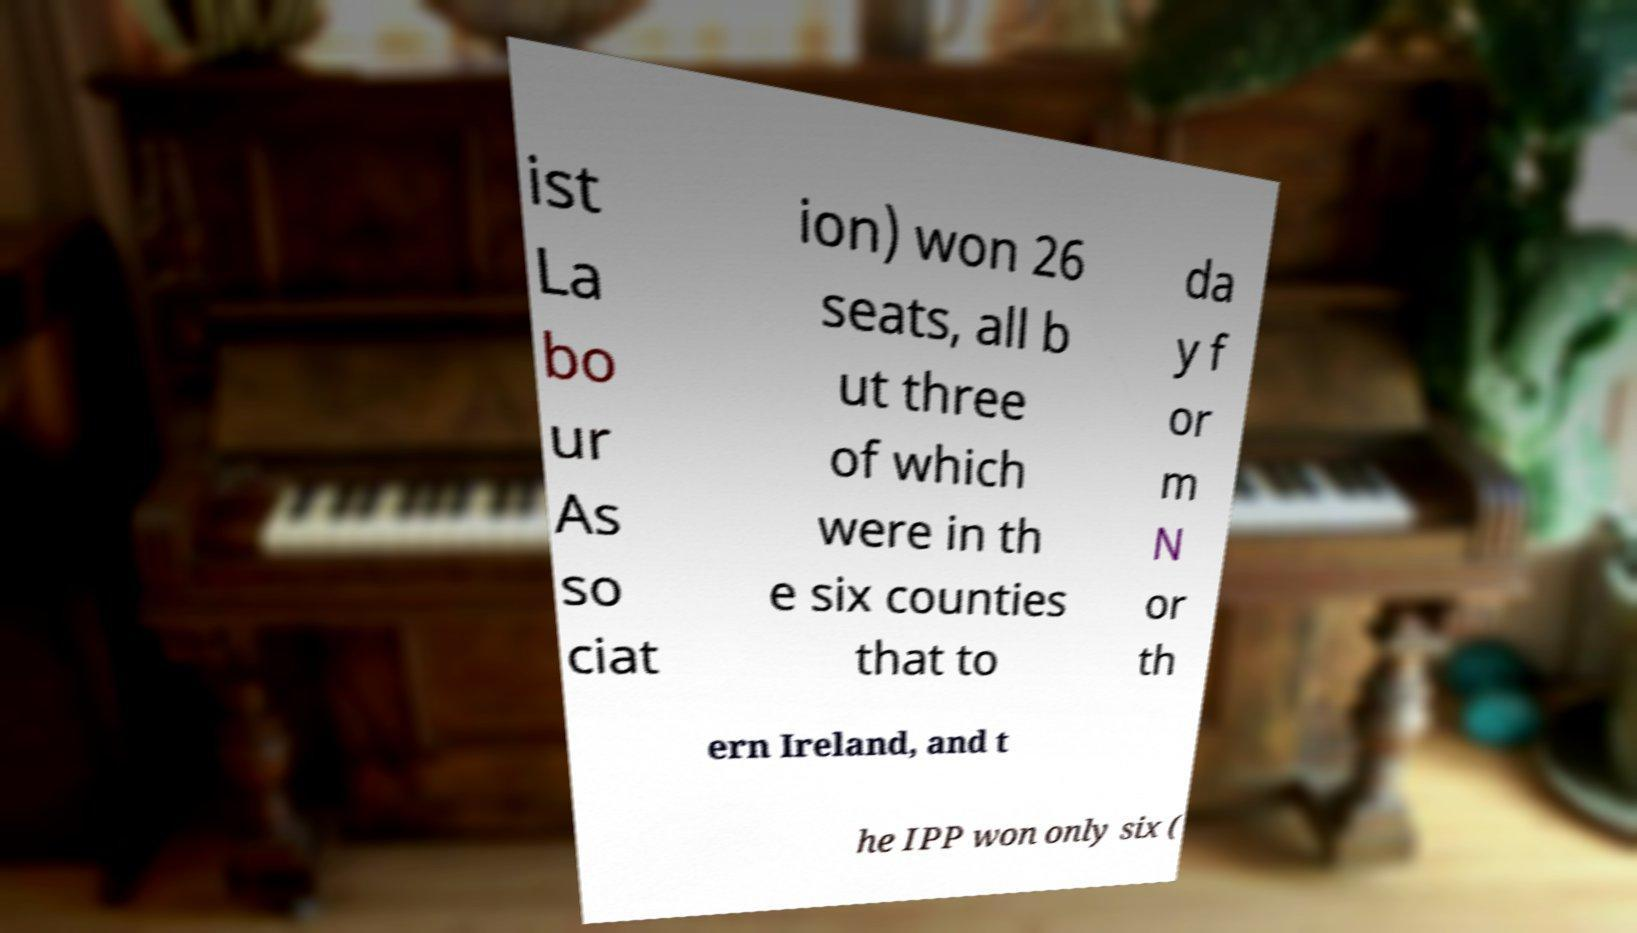Can you accurately transcribe the text from the provided image for me? ist La bo ur As so ciat ion) won 26 seats, all b ut three of which were in th e six counties that to da y f or m N or th ern Ireland, and t he IPP won only six ( 